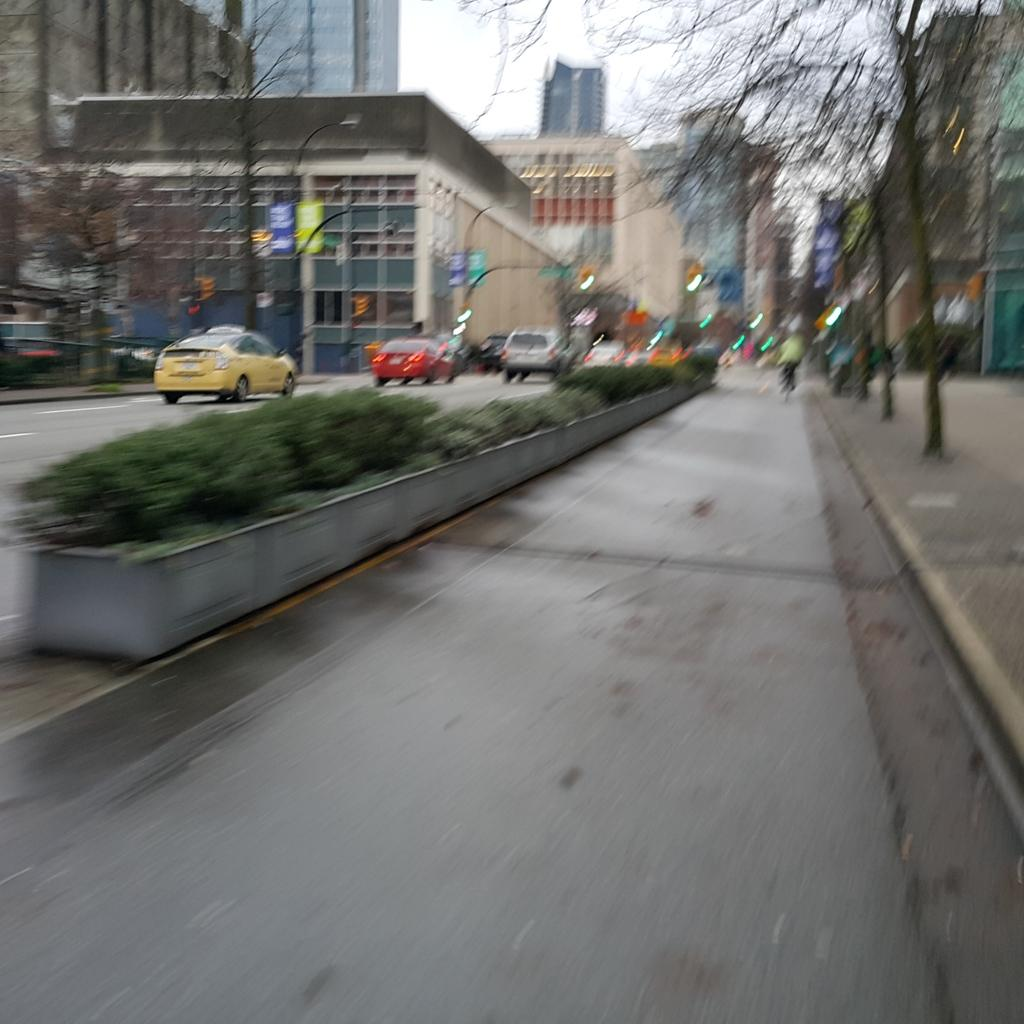What can be seen on the road in the image? There are vehicles on the road in the image. What type of vegetation is present near the road? There are trees beside the road in the image. What structures are visible in the image? There are buildings visible in the image. What traffic control devices are present in the background of the image? Traffic lights are present in the background of the image. What type of advertising is visible in the background of the image? Hoardings are visible in the background of the image. What color is the brain of the person walking on the road in the image? There is no person walking on the road in the image, and therefore no brain is visible. Can you make a request to the hoarding in the image to change its advertisement? The hoarding in the image is a static object and cannot respond to requests. 